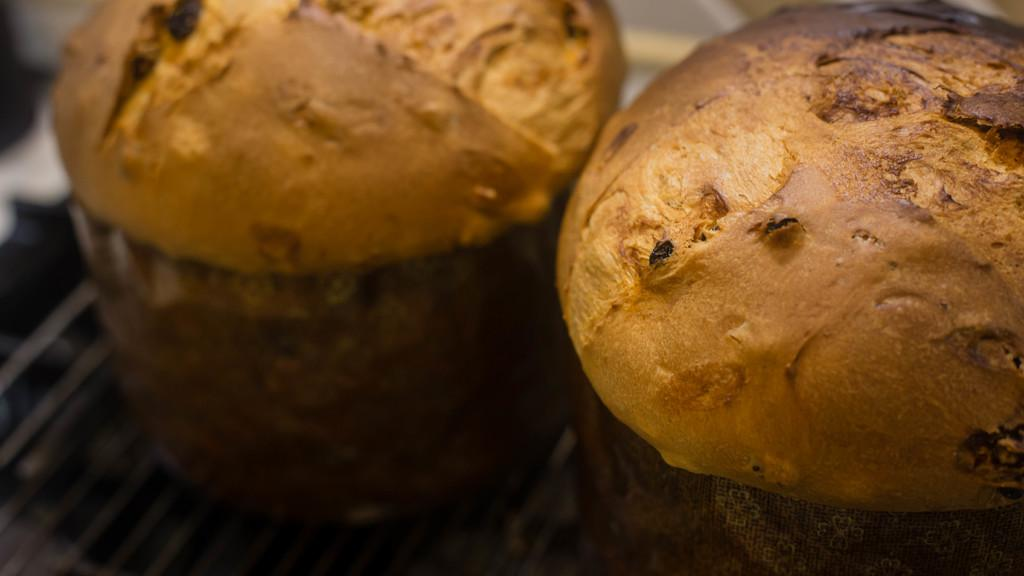What type of objects can be seen in the image? There are food items in the image. What type of bread is being used to show respect for the property in the image? There is no bread, respect, or property present in the image. 